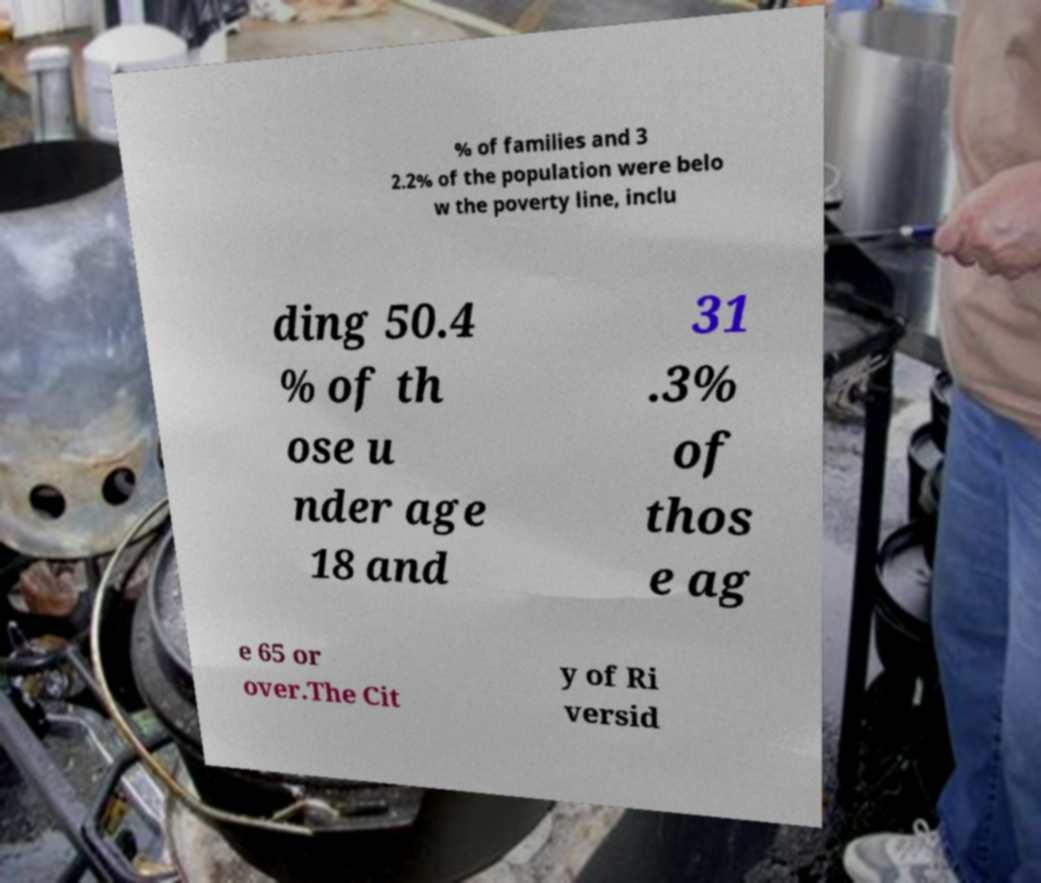What messages or text are displayed in this image? I need them in a readable, typed format. % of families and 3 2.2% of the population were belo w the poverty line, inclu ding 50.4 % of th ose u nder age 18 and 31 .3% of thos e ag e 65 or over.The Cit y of Ri versid 